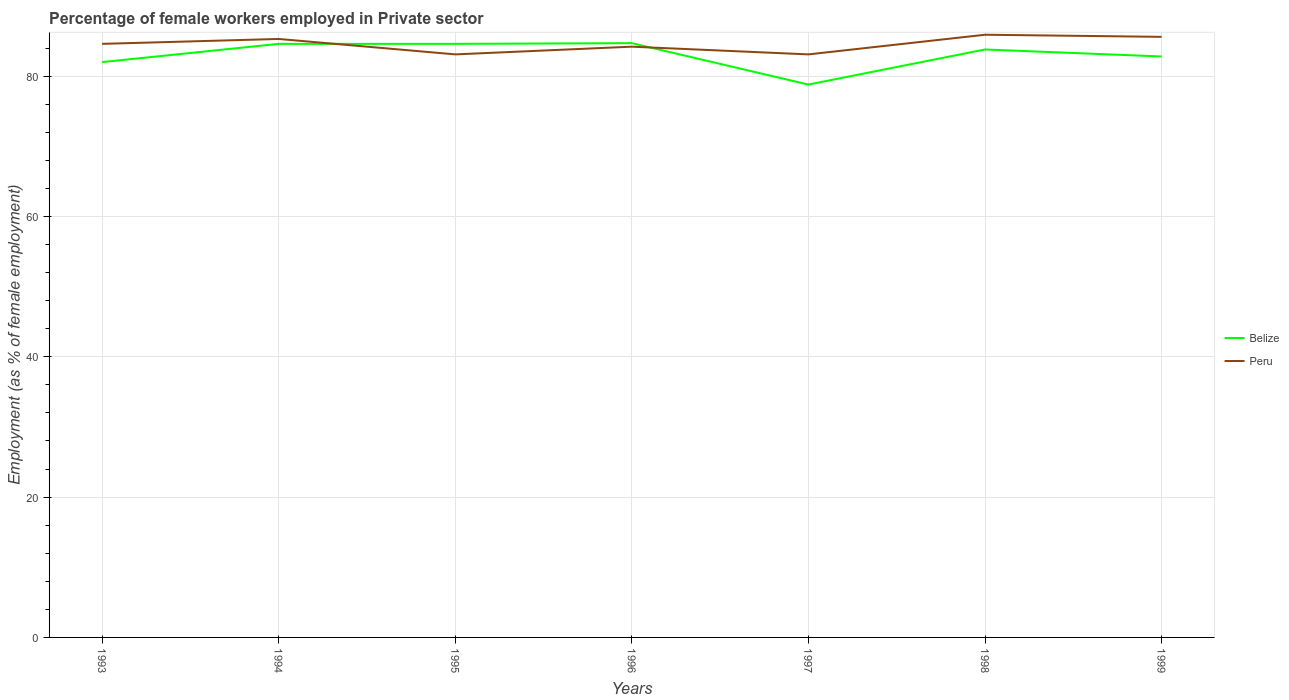Does the line corresponding to Belize intersect with the line corresponding to Peru?
Offer a very short reply. Yes. Across all years, what is the maximum percentage of females employed in Private sector in Peru?
Provide a succinct answer. 83.1. In which year was the percentage of females employed in Private sector in Belize maximum?
Offer a very short reply. 1997. What is the total percentage of females employed in Private sector in Peru in the graph?
Give a very brief answer. -2.8. What is the difference between the highest and the second highest percentage of females employed in Private sector in Peru?
Your answer should be compact. 2.8. How many lines are there?
Make the answer very short. 2. How many years are there in the graph?
Keep it short and to the point. 7. Does the graph contain any zero values?
Your answer should be compact. No. Does the graph contain grids?
Provide a succinct answer. Yes. Where does the legend appear in the graph?
Make the answer very short. Center right. How many legend labels are there?
Keep it short and to the point. 2. How are the legend labels stacked?
Make the answer very short. Vertical. What is the title of the graph?
Offer a terse response. Percentage of female workers employed in Private sector. What is the label or title of the X-axis?
Provide a short and direct response. Years. What is the label or title of the Y-axis?
Ensure brevity in your answer.  Employment (as % of female employment). What is the Employment (as % of female employment) of Peru in 1993?
Ensure brevity in your answer.  84.6. What is the Employment (as % of female employment) of Belize in 1994?
Provide a succinct answer. 84.6. What is the Employment (as % of female employment) of Peru in 1994?
Offer a very short reply. 85.3. What is the Employment (as % of female employment) of Belize in 1995?
Give a very brief answer. 84.6. What is the Employment (as % of female employment) of Peru in 1995?
Offer a very short reply. 83.1. What is the Employment (as % of female employment) of Belize in 1996?
Your answer should be compact. 84.7. What is the Employment (as % of female employment) in Peru in 1996?
Provide a succinct answer. 84.2. What is the Employment (as % of female employment) in Belize in 1997?
Make the answer very short. 78.8. What is the Employment (as % of female employment) of Peru in 1997?
Provide a succinct answer. 83.1. What is the Employment (as % of female employment) of Belize in 1998?
Provide a short and direct response. 83.8. What is the Employment (as % of female employment) of Peru in 1998?
Your response must be concise. 85.9. What is the Employment (as % of female employment) in Belize in 1999?
Your response must be concise. 82.8. What is the Employment (as % of female employment) of Peru in 1999?
Your answer should be very brief. 85.6. Across all years, what is the maximum Employment (as % of female employment) of Belize?
Keep it short and to the point. 84.7. Across all years, what is the maximum Employment (as % of female employment) of Peru?
Offer a terse response. 85.9. Across all years, what is the minimum Employment (as % of female employment) of Belize?
Offer a very short reply. 78.8. Across all years, what is the minimum Employment (as % of female employment) of Peru?
Give a very brief answer. 83.1. What is the total Employment (as % of female employment) in Belize in the graph?
Your answer should be very brief. 581.3. What is the total Employment (as % of female employment) in Peru in the graph?
Ensure brevity in your answer.  591.8. What is the difference between the Employment (as % of female employment) in Belize in 1993 and that in 1994?
Keep it short and to the point. -2.6. What is the difference between the Employment (as % of female employment) of Belize in 1993 and that in 1995?
Offer a terse response. -2.6. What is the difference between the Employment (as % of female employment) of Peru in 1993 and that in 1995?
Make the answer very short. 1.5. What is the difference between the Employment (as % of female employment) in Belize in 1993 and that in 1996?
Make the answer very short. -2.7. What is the difference between the Employment (as % of female employment) of Peru in 1993 and that in 1996?
Provide a short and direct response. 0.4. What is the difference between the Employment (as % of female employment) in Belize in 1993 and that in 1997?
Give a very brief answer. 3.2. What is the difference between the Employment (as % of female employment) of Belize in 1993 and that in 1998?
Give a very brief answer. -1.8. What is the difference between the Employment (as % of female employment) in Belize in 1993 and that in 1999?
Provide a short and direct response. -0.8. What is the difference between the Employment (as % of female employment) in Belize in 1994 and that in 1995?
Provide a succinct answer. 0. What is the difference between the Employment (as % of female employment) in Belize in 1994 and that in 1996?
Ensure brevity in your answer.  -0.1. What is the difference between the Employment (as % of female employment) of Peru in 1994 and that in 1996?
Offer a very short reply. 1.1. What is the difference between the Employment (as % of female employment) in Belize in 1994 and that in 1997?
Your answer should be compact. 5.8. What is the difference between the Employment (as % of female employment) of Peru in 1994 and that in 1997?
Your response must be concise. 2.2. What is the difference between the Employment (as % of female employment) in Peru in 1995 and that in 1996?
Provide a short and direct response. -1.1. What is the difference between the Employment (as % of female employment) of Belize in 1995 and that in 1997?
Your response must be concise. 5.8. What is the difference between the Employment (as % of female employment) in Peru in 1995 and that in 1998?
Offer a terse response. -2.8. What is the difference between the Employment (as % of female employment) of Peru in 1996 and that in 1997?
Ensure brevity in your answer.  1.1. What is the difference between the Employment (as % of female employment) in Belize in 1996 and that in 1998?
Your answer should be compact. 0.9. What is the difference between the Employment (as % of female employment) of Peru in 1996 and that in 1998?
Your response must be concise. -1.7. What is the difference between the Employment (as % of female employment) of Belize in 1996 and that in 1999?
Keep it short and to the point. 1.9. What is the difference between the Employment (as % of female employment) in Belize in 1993 and the Employment (as % of female employment) in Peru in 1995?
Give a very brief answer. -1.1. What is the difference between the Employment (as % of female employment) in Belize in 1993 and the Employment (as % of female employment) in Peru in 1997?
Your response must be concise. -1.1. What is the difference between the Employment (as % of female employment) of Belize in 1993 and the Employment (as % of female employment) of Peru in 1999?
Keep it short and to the point. -3.6. What is the difference between the Employment (as % of female employment) in Belize in 1994 and the Employment (as % of female employment) in Peru in 1995?
Your response must be concise. 1.5. What is the difference between the Employment (as % of female employment) of Belize in 1994 and the Employment (as % of female employment) of Peru in 1998?
Make the answer very short. -1.3. What is the difference between the Employment (as % of female employment) in Belize in 1995 and the Employment (as % of female employment) in Peru in 1998?
Provide a short and direct response. -1.3. What is the difference between the Employment (as % of female employment) of Belize in 1997 and the Employment (as % of female employment) of Peru in 1998?
Give a very brief answer. -7.1. What is the difference between the Employment (as % of female employment) in Belize in 1997 and the Employment (as % of female employment) in Peru in 1999?
Your response must be concise. -6.8. What is the difference between the Employment (as % of female employment) of Belize in 1998 and the Employment (as % of female employment) of Peru in 1999?
Provide a short and direct response. -1.8. What is the average Employment (as % of female employment) in Belize per year?
Your answer should be very brief. 83.04. What is the average Employment (as % of female employment) of Peru per year?
Keep it short and to the point. 84.54. In the year 1993, what is the difference between the Employment (as % of female employment) in Belize and Employment (as % of female employment) in Peru?
Your answer should be very brief. -2.6. In the year 1996, what is the difference between the Employment (as % of female employment) of Belize and Employment (as % of female employment) of Peru?
Your answer should be very brief. 0.5. In the year 1997, what is the difference between the Employment (as % of female employment) of Belize and Employment (as % of female employment) of Peru?
Ensure brevity in your answer.  -4.3. In the year 1998, what is the difference between the Employment (as % of female employment) of Belize and Employment (as % of female employment) of Peru?
Offer a very short reply. -2.1. What is the ratio of the Employment (as % of female employment) in Belize in 1993 to that in 1994?
Provide a succinct answer. 0.97. What is the ratio of the Employment (as % of female employment) of Peru in 1993 to that in 1994?
Offer a terse response. 0.99. What is the ratio of the Employment (as % of female employment) of Belize in 1993 to that in 1995?
Your response must be concise. 0.97. What is the ratio of the Employment (as % of female employment) in Peru in 1993 to that in 1995?
Provide a short and direct response. 1.02. What is the ratio of the Employment (as % of female employment) of Belize in 1993 to that in 1996?
Provide a short and direct response. 0.97. What is the ratio of the Employment (as % of female employment) in Belize in 1993 to that in 1997?
Offer a terse response. 1.04. What is the ratio of the Employment (as % of female employment) in Peru in 1993 to that in 1997?
Your answer should be compact. 1.02. What is the ratio of the Employment (as % of female employment) in Belize in 1993 to that in 1998?
Make the answer very short. 0.98. What is the ratio of the Employment (as % of female employment) in Peru in 1993 to that in 1998?
Make the answer very short. 0.98. What is the ratio of the Employment (as % of female employment) of Belize in 1993 to that in 1999?
Keep it short and to the point. 0.99. What is the ratio of the Employment (as % of female employment) of Peru in 1993 to that in 1999?
Offer a terse response. 0.99. What is the ratio of the Employment (as % of female employment) in Belize in 1994 to that in 1995?
Provide a succinct answer. 1. What is the ratio of the Employment (as % of female employment) in Peru in 1994 to that in 1995?
Your answer should be very brief. 1.03. What is the ratio of the Employment (as % of female employment) of Peru in 1994 to that in 1996?
Ensure brevity in your answer.  1.01. What is the ratio of the Employment (as % of female employment) of Belize in 1994 to that in 1997?
Provide a succinct answer. 1.07. What is the ratio of the Employment (as % of female employment) of Peru in 1994 to that in 1997?
Your answer should be compact. 1.03. What is the ratio of the Employment (as % of female employment) of Belize in 1994 to that in 1998?
Ensure brevity in your answer.  1.01. What is the ratio of the Employment (as % of female employment) in Peru in 1994 to that in 1998?
Offer a very short reply. 0.99. What is the ratio of the Employment (as % of female employment) in Belize in 1994 to that in 1999?
Ensure brevity in your answer.  1.02. What is the ratio of the Employment (as % of female employment) of Peru in 1995 to that in 1996?
Make the answer very short. 0.99. What is the ratio of the Employment (as % of female employment) in Belize in 1995 to that in 1997?
Offer a terse response. 1.07. What is the ratio of the Employment (as % of female employment) in Belize in 1995 to that in 1998?
Your response must be concise. 1.01. What is the ratio of the Employment (as % of female employment) of Peru in 1995 to that in 1998?
Provide a succinct answer. 0.97. What is the ratio of the Employment (as % of female employment) in Belize in 1995 to that in 1999?
Your response must be concise. 1.02. What is the ratio of the Employment (as % of female employment) of Peru in 1995 to that in 1999?
Ensure brevity in your answer.  0.97. What is the ratio of the Employment (as % of female employment) in Belize in 1996 to that in 1997?
Offer a terse response. 1.07. What is the ratio of the Employment (as % of female employment) in Peru in 1996 to that in 1997?
Offer a very short reply. 1.01. What is the ratio of the Employment (as % of female employment) in Belize in 1996 to that in 1998?
Ensure brevity in your answer.  1.01. What is the ratio of the Employment (as % of female employment) of Peru in 1996 to that in 1998?
Ensure brevity in your answer.  0.98. What is the ratio of the Employment (as % of female employment) of Belize in 1996 to that in 1999?
Offer a terse response. 1.02. What is the ratio of the Employment (as % of female employment) in Peru in 1996 to that in 1999?
Offer a terse response. 0.98. What is the ratio of the Employment (as % of female employment) in Belize in 1997 to that in 1998?
Make the answer very short. 0.94. What is the ratio of the Employment (as % of female employment) in Peru in 1997 to that in 1998?
Offer a terse response. 0.97. What is the ratio of the Employment (as % of female employment) in Belize in 1997 to that in 1999?
Provide a short and direct response. 0.95. What is the ratio of the Employment (as % of female employment) in Peru in 1997 to that in 1999?
Make the answer very short. 0.97. What is the ratio of the Employment (as % of female employment) of Belize in 1998 to that in 1999?
Your response must be concise. 1.01. What is the ratio of the Employment (as % of female employment) of Peru in 1998 to that in 1999?
Make the answer very short. 1. What is the difference between the highest and the second highest Employment (as % of female employment) in Peru?
Provide a succinct answer. 0.3. What is the difference between the highest and the lowest Employment (as % of female employment) in Belize?
Provide a short and direct response. 5.9. What is the difference between the highest and the lowest Employment (as % of female employment) of Peru?
Your answer should be compact. 2.8. 